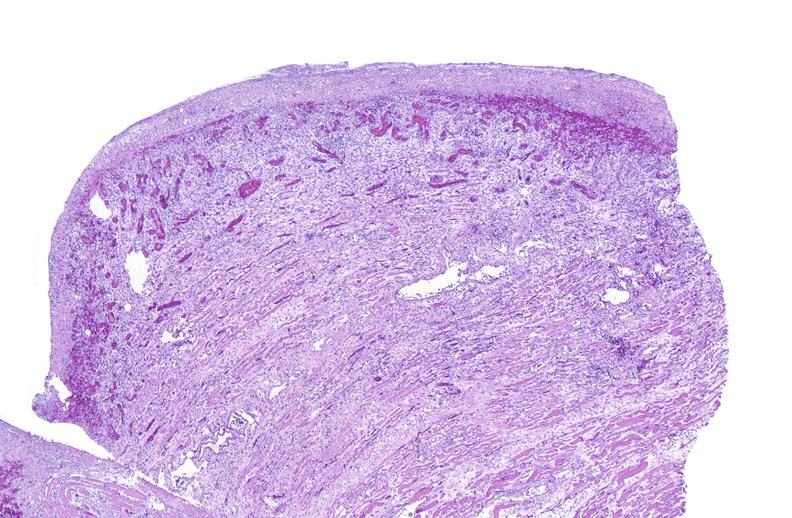does linear fracture in occiput show tracheotomy, granulation tissue?
Answer the question using a single word or phrase. No 